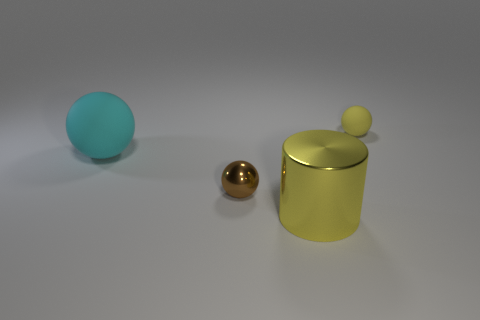Is there any particular theme or style that this image seems to represent? The image has a minimalist aesthetic, with a focus on simple shapes and a limited color palette. The clean lines, restrained use of colors, and the contrast between the matte and metallic finishes contribute to a modern and sophisticated look that underscores the beauty of simplicity and could be seen as a representation of contemporary design themes. 